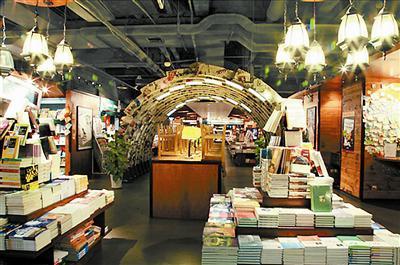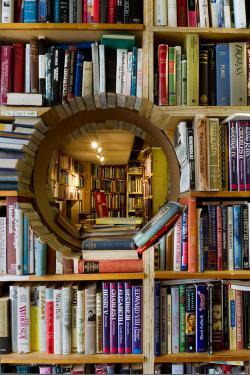The first image is the image on the left, the second image is the image on the right. Assess this claim about the two images: "There is a bicycle hanging from the ceiling.". Correct or not? Answer yes or no. No. The first image is the image on the left, the second image is the image on the right. Given the left and right images, does the statement "One of the images includes a bicycle suspended in the air." hold true? Answer yes or no. No. 